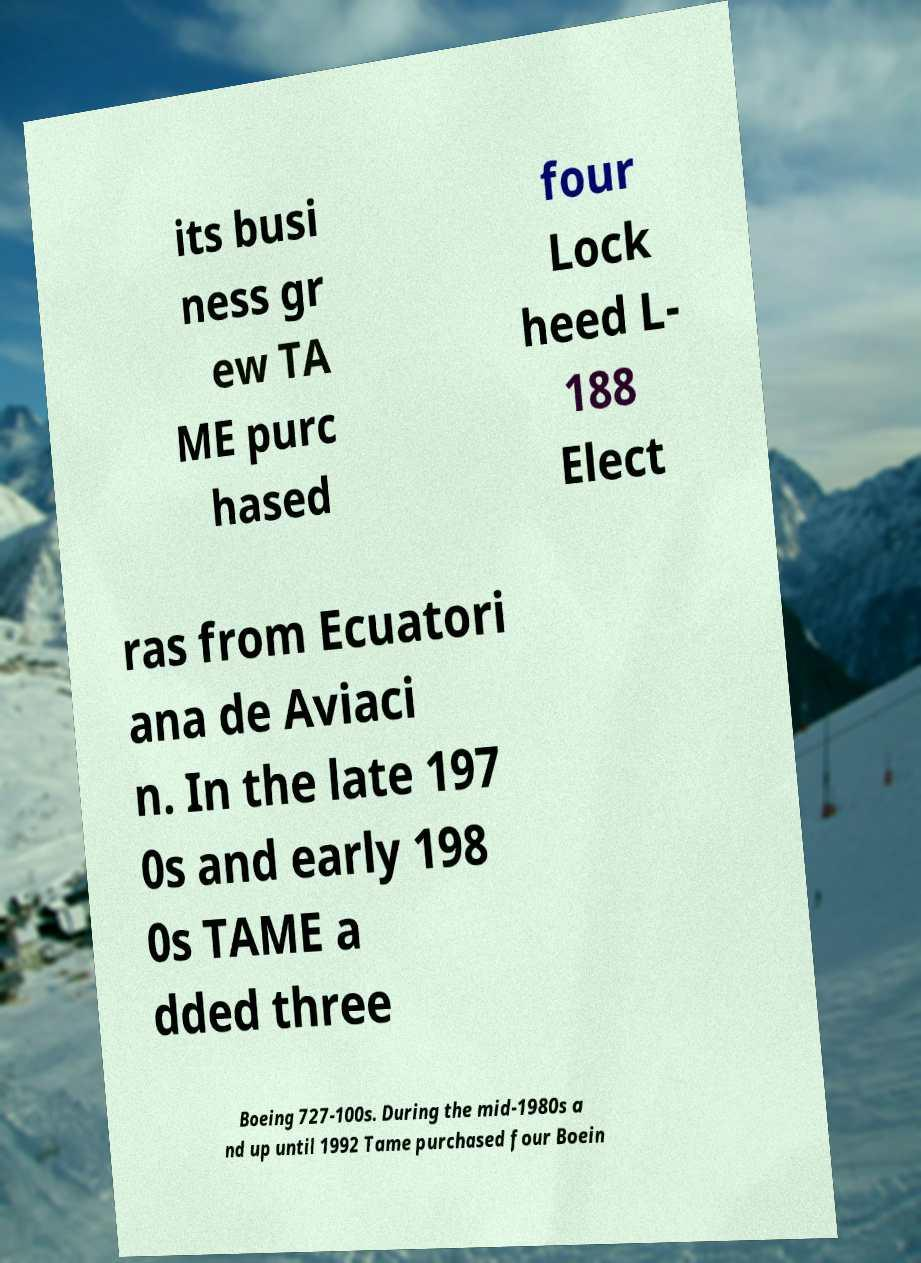Can you accurately transcribe the text from the provided image for me? its busi ness gr ew TA ME purc hased four Lock heed L- 188 Elect ras from Ecuatori ana de Aviaci n. In the late 197 0s and early 198 0s TAME a dded three Boeing 727-100s. During the mid-1980s a nd up until 1992 Tame purchased four Boein 